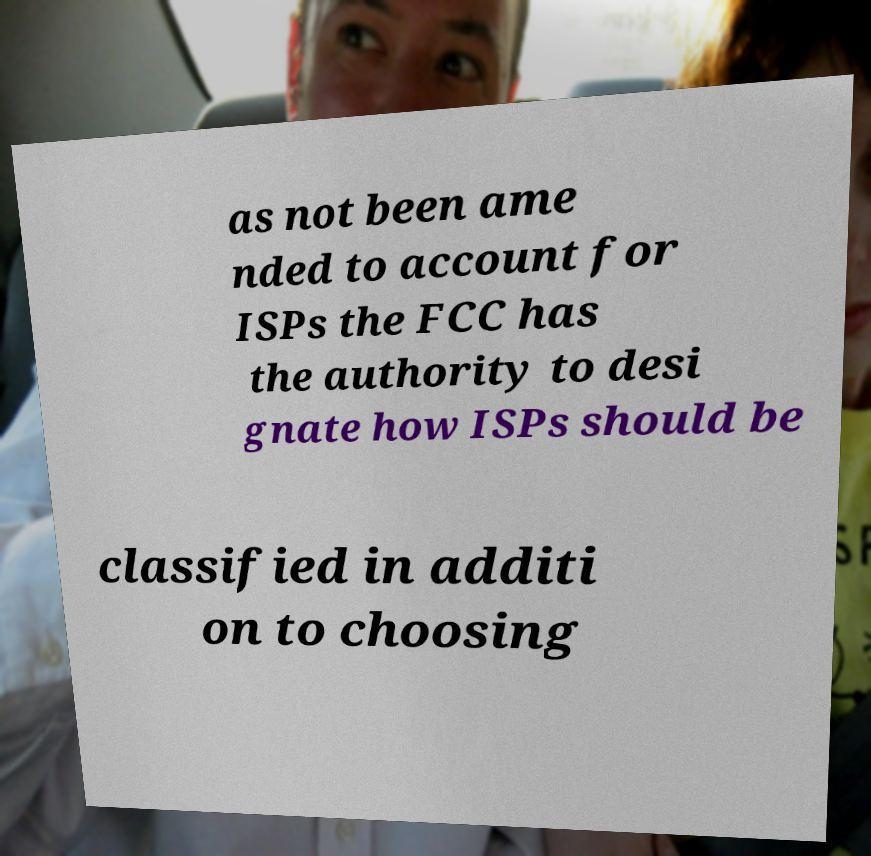Could you assist in decoding the text presented in this image and type it out clearly? as not been ame nded to account for ISPs the FCC has the authority to desi gnate how ISPs should be classified in additi on to choosing 